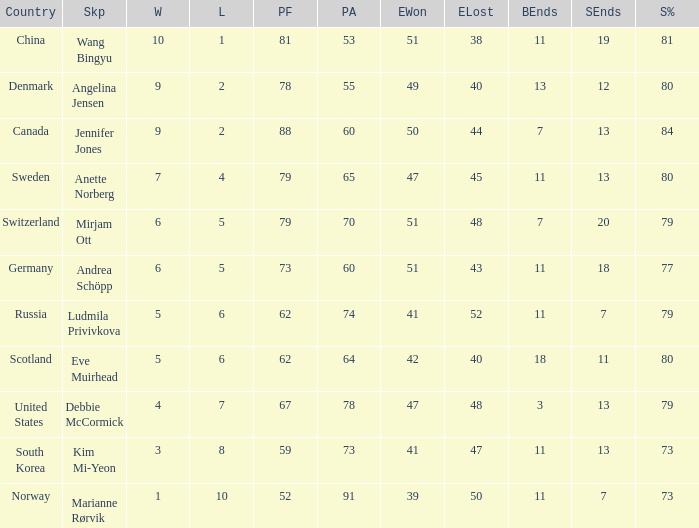Andrea Schöpp is the skip of which country? Germany. Give me the full table as a dictionary. {'header': ['Country', 'Skp', 'W', 'L', 'PF', 'PA', 'EWon', 'ELost', 'BEnds', 'SEnds', 'S%'], 'rows': [['China', 'Wang Bingyu', '10', '1', '81', '53', '51', '38', '11', '19', '81'], ['Denmark', 'Angelina Jensen', '9', '2', '78', '55', '49', '40', '13', '12', '80'], ['Canada', 'Jennifer Jones', '9', '2', '88', '60', '50', '44', '7', '13', '84'], ['Sweden', 'Anette Norberg', '7', '4', '79', '65', '47', '45', '11', '13', '80'], ['Switzerland', 'Mirjam Ott', '6', '5', '79', '70', '51', '48', '7', '20', '79'], ['Germany', 'Andrea Schöpp', '6', '5', '73', '60', '51', '43', '11', '18', '77'], ['Russia', 'Ludmila Privivkova', '5', '6', '62', '74', '41', '52', '11', '7', '79'], ['Scotland', 'Eve Muirhead', '5', '6', '62', '64', '42', '40', '18', '11', '80'], ['United States', 'Debbie McCormick', '4', '7', '67', '78', '47', '48', '3', '13', '79'], ['South Korea', 'Kim Mi-Yeon', '3', '8', '59', '73', '41', '47', '11', '13', '73'], ['Norway', 'Marianne Rørvik', '1', '10', '52', '91', '39', '50', '11', '7', '73']]} 